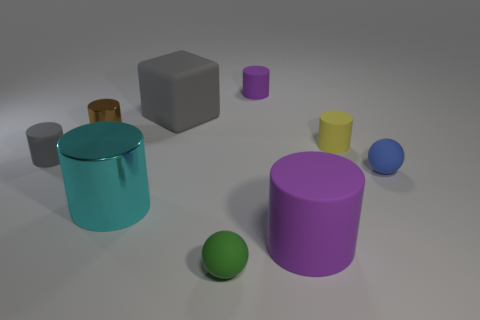Subtract 3 cylinders. How many cylinders are left? 3 Subtract all yellow cylinders. How many cylinders are left? 5 Subtract all big purple cylinders. How many cylinders are left? 5 Subtract all purple cylinders. Subtract all purple cubes. How many cylinders are left? 4 Add 1 tiny blue matte balls. How many objects exist? 10 Subtract all cylinders. How many objects are left? 3 Subtract all small yellow metal spheres. Subtract all tiny purple rubber cylinders. How many objects are left? 8 Add 8 rubber balls. How many rubber balls are left? 10 Add 1 small purple matte cubes. How many small purple matte cubes exist? 1 Subtract 1 gray cylinders. How many objects are left? 8 